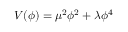<formula> <loc_0><loc_0><loc_500><loc_500>V ( \phi ) = \mu ^ { 2 } \phi ^ { 2 } + \lambda \phi ^ { 4 }</formula> 